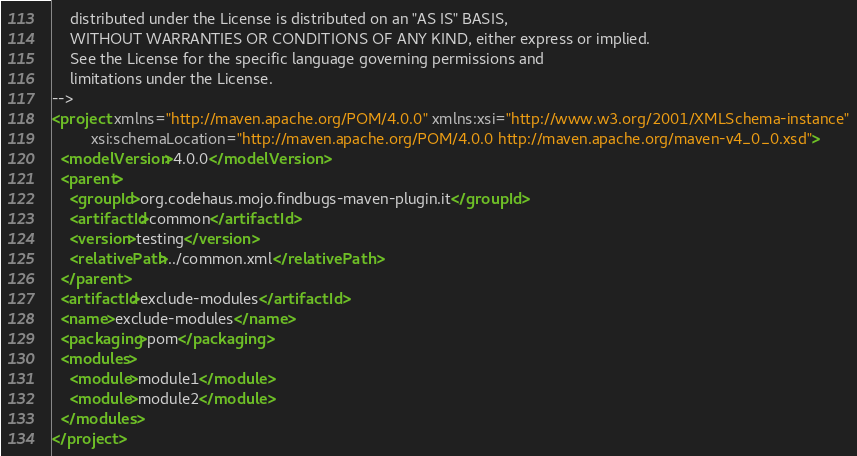Convert code to text. <code><loc_0><loc_0><loc_500><loc_500><_XML_>    distributed under the License is distributed on an "AS IS" BASIS,
    WITHOUT WARRANTIES OR CONDITIONS OF ANY KIND, either express or implied.
    See the License for the specific language governing permissions and
    limitations under the License.
-->
<project xmlns="http://maven.apache.org/POM/4.0.0" xmlns:xsi="http://www.w3.org/2001/XMLSchema-instance"
         xsi:schemaLocation="http://maven.apache.org/POM/4.0.0 http://maven.apache.org/maven-v4_0_0.xsd">
  <modelVersion>4.0.0</modelVersion>
  <parent>
    <groupId>org.codehaus.mojo.findbugs-maven-plugin.it</groupId>
    <artifactId>common</artifactId>
    <version>testing</version>
    <relativePath>../common.xml</relativePath>
  </parent>
  <artifactId>exclude-modules</artifactId>
  <name>exclude-modules</name>
  <packaging>pom</packaging>
  <modules>
    <module>module1</module>
    <module>module2</module>
  </modules>
</project></code> 